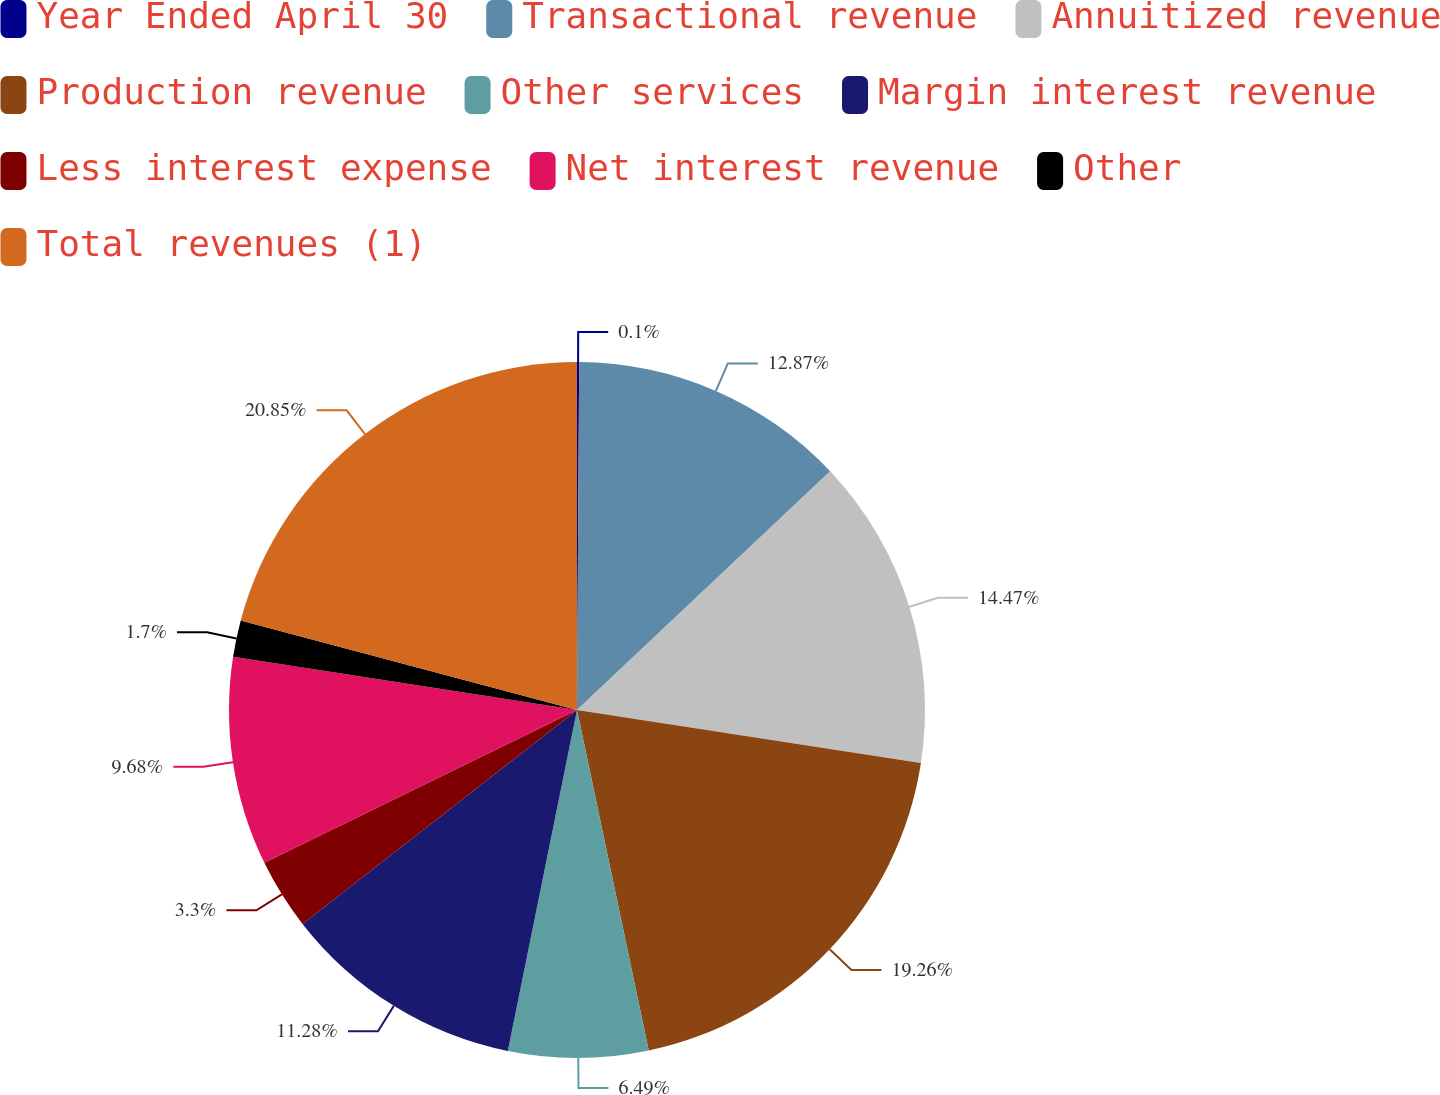<chart> <loc_0><loc_0><loc_500><loc_500><pie_chart><fcel>Year Ended April 30<fcel>Transactional revenue<fcel>Annuitized revenue<fcel>Production revenue<fcel>Other services<fcel>Margin interest revenue<fcel>Less interest expense<fcel>Net interest revenue<fcel>Other<fcel>Total revenues (1)<nl><fcel>0.1%<fcel>12.87%<fcel>14.47%<fcel>19.26%<fcel>6.49%<fcel>11.28%<fcel>3.3%<fcel>9.68%<fcel>1.7%<fcel>20.86%<nl></chart> 